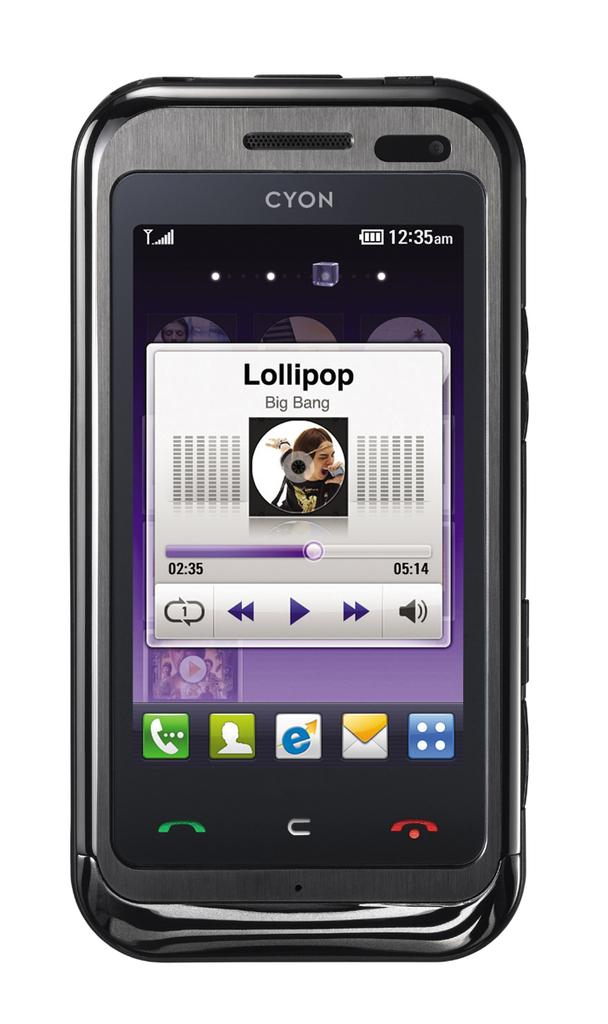<image>
Offer a succinct explanation of the picture presented. A cyon phone is showing that a song by big bang is being played 